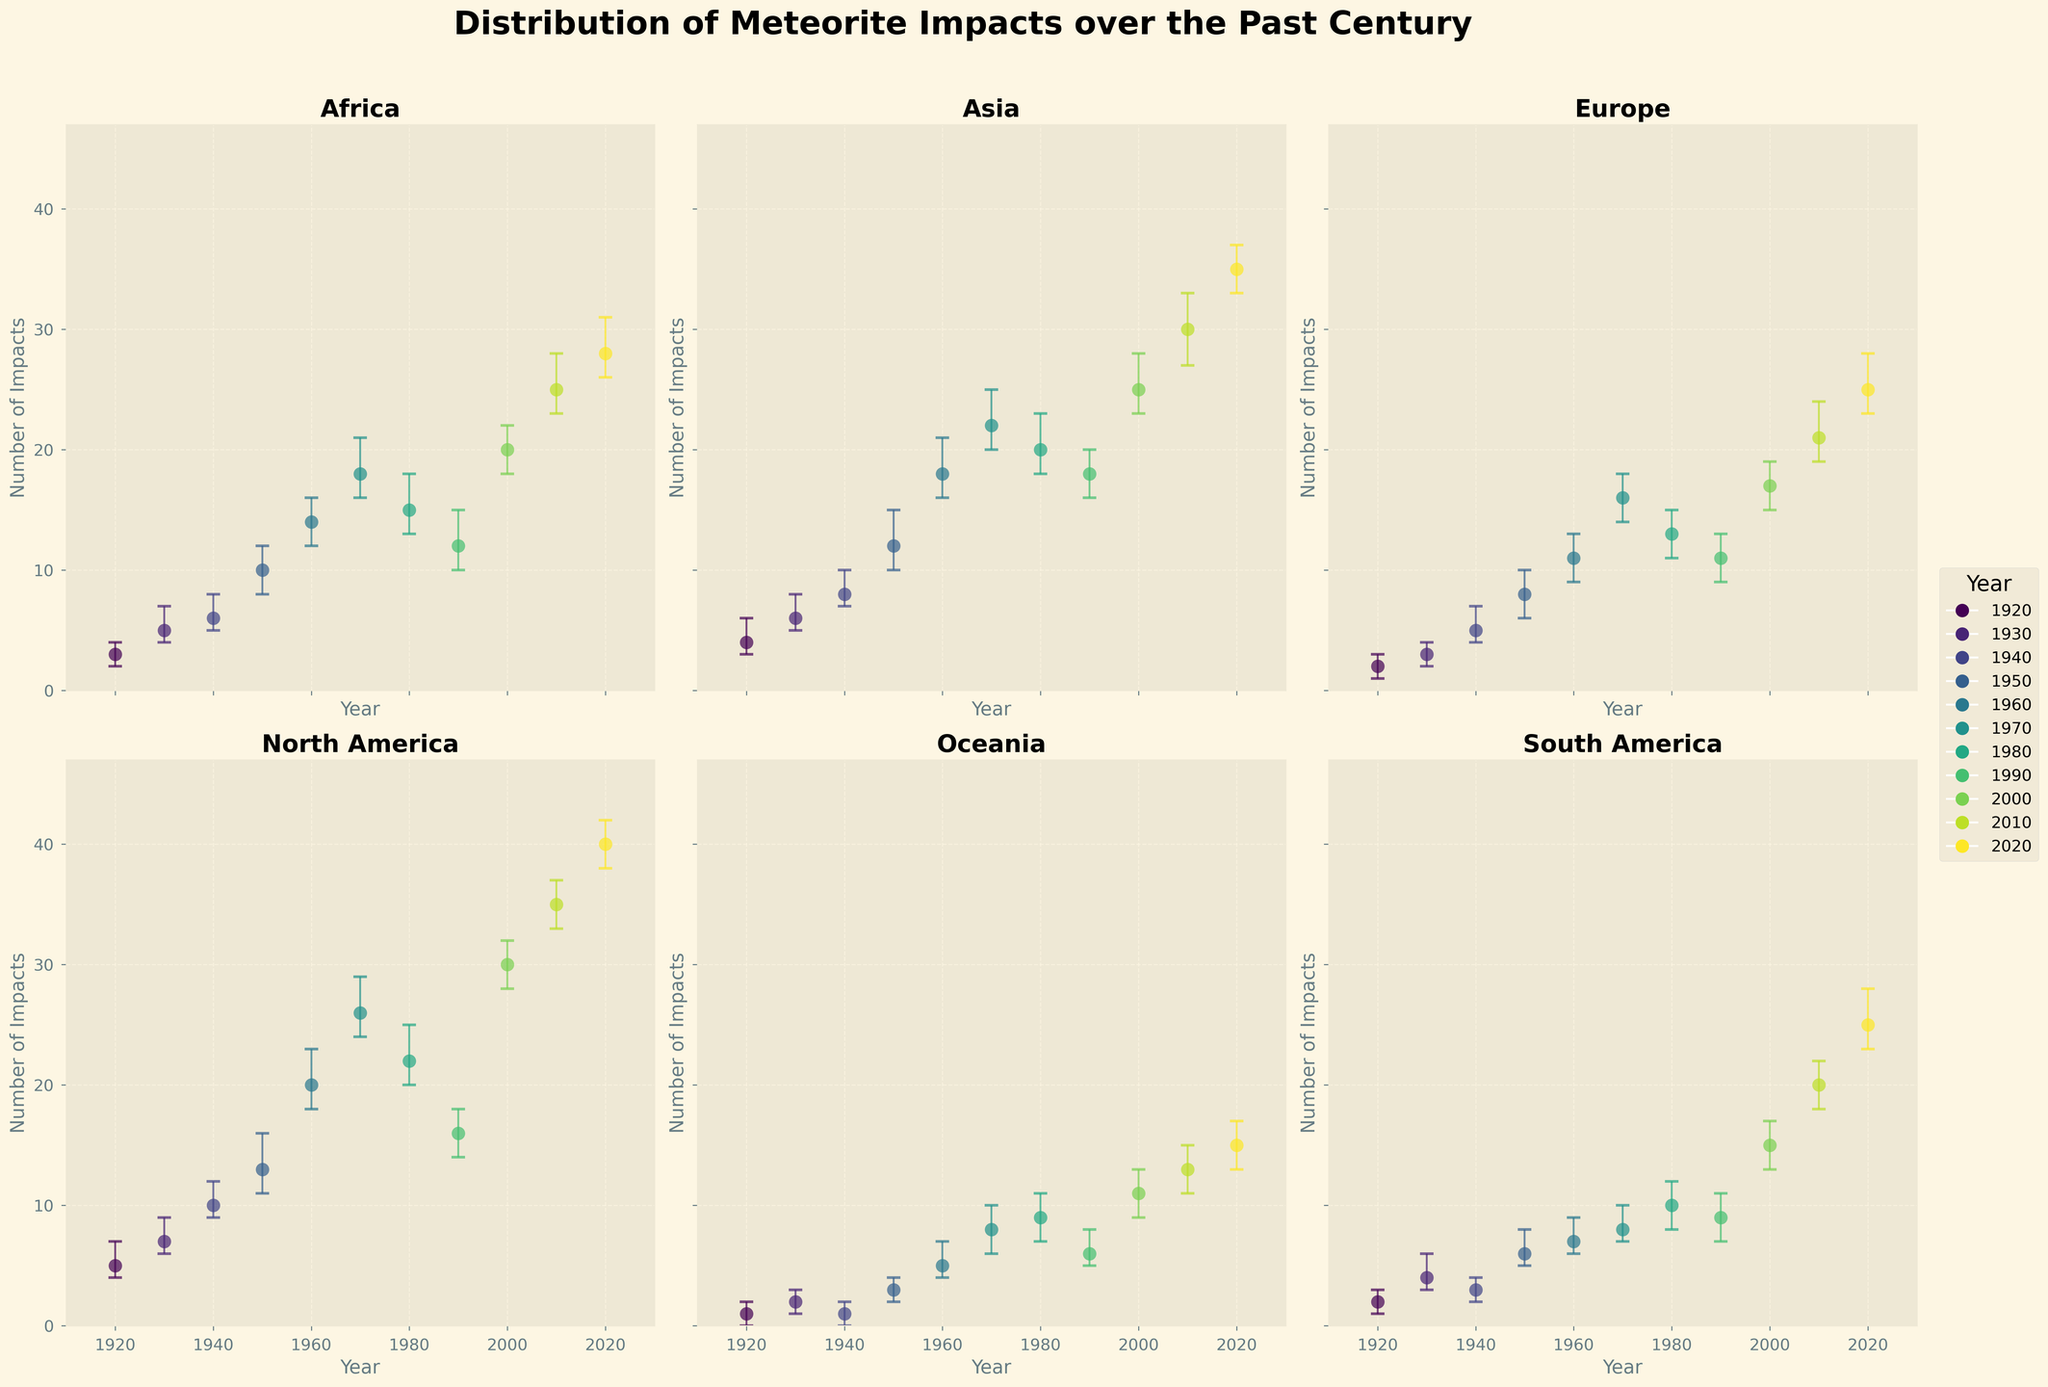What is the title of the figure? The title is located at the top of the figure, summarizing the subject of the plots.
Answer: Distribution of Meteorite Impacts over the Past Century Which continent experienced the highest number of meteorite impacts in 2020? The number of impacts for each continent in 2020 can be found by locating the points or error bars labeled with the year 2020 in each subplot. North America shows around 40 impacts.
Answer: North America Which continent shows the smallest number of meteorite impacts in 1930? By looking at the points or error bars in each subplot corresponding to the year 1930, Oceania has the smallest number with 2 impacts.
Answer: Oceania In which decade did Asia surpass 30 meteorite impacts for the first time? By observing the increase in the number of impacts for Asia over the decades, Asia surpasses 30 impacts for the first time in 2010.
Answer: 2010 What is the confidence interval for Europe in 1940? Each error bar's vertical lines represent the confidence intervals. For Europe in 1940, the error bar spans from 4 to 7 impacts.
Answer: 4 to 7 How does the number of meteorite impacts in North America in 1960 compare to that in Europe in 1980? Locate the data points for these years and continents. North America in 1960 has 20 impacts, and Europe in 1980 has 13 impacts. North America has 7 more impacts.
Answer: 7 more in North America Between which two subsequent decades did South America see the largest increase in meteorite impacts? To find the largest increase, compare the differences between subsequent decades in South America's subplot. The jump from 2000 (15 impacts) to 2010 (20 impacts) is the largest increase of 5 impacts.
Answer: 2000 to 2010 Which continent shows the smallest variation in the number of impacts between 1920 and 1930? Measure the spread between the number of impacts in the two decades for each continent. Oceania shifts by only 1 impact (1 to 2).
Answer: Oceania How many continents surpassed 15 meteorite impacts in 2000? Check each subplot for the number of impacts that are greater than 15 in the year 2000. Africa, Asia, Europe, North America, and South America surpassed 15.
Answer: 5 continents What is the trend in the number of meteorite impacts for Africa from 1920 to 2020? Observe the data points for Africa over the decades. The number of impacts generally increases consistently from 3 in 1920 to 28 in 2020.
Answer: Increasing trend 